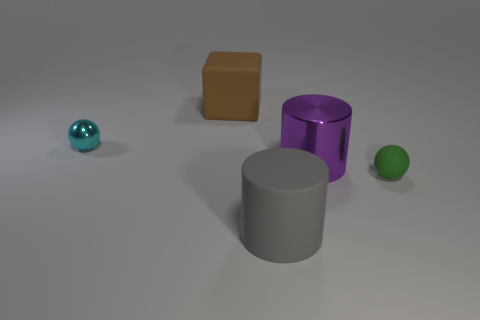What is the texture of the objects' surfaces? The objects in the image have a smooth texture with a matte finish that reflects a bit of light, giving them a realistic appearance. There aren't any visible patterns or roughness on their surfaces. 